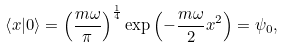Convert formula to latex. <formula><loc_0><loc_0><loc_500><loc_500>\left \langle x | 0 \right \rangle = \left ( { \frac { m \omega } { \pi } } \right ) ^ { \frac { 1 } { 4 } } \exp \left ( - { \frac { m \omega } { 2 } } x ^ { 2 } \right ) = \psi _ { 0 } ,</formula> 